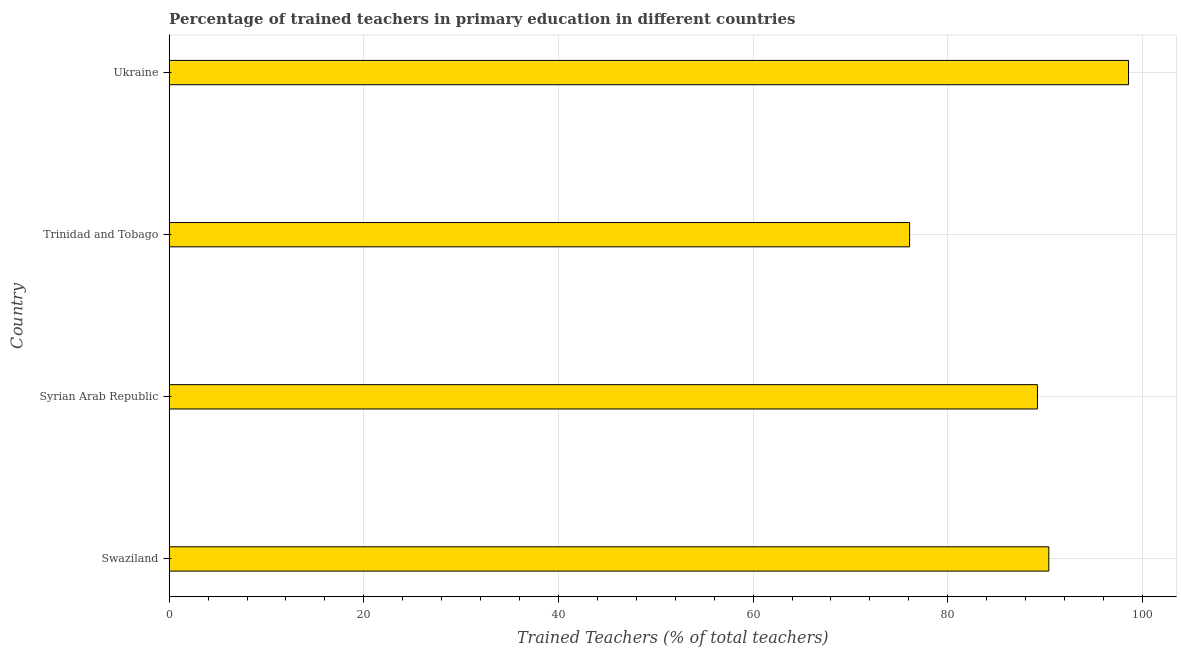Does the graph contain any zero values?
Offer a terse response. No. Does the graph contain grids?
Make the answer very short. Yes. What is the title of the graph?
Your response must be concise. Percentage of trained teachers in primary education in different countries. What is the label or title of the X-axis?
Give a very brief answer. Trained Teachers (% of total teachers). What is the label or title of the Y-axis?
Your answer should be compact. Country. What is the percentage of trained teachers in Syrian Arab Republic?
Provide a short and direct response. 89.21. Across all countries, what is the maximum percentage of trained teachers?
Offer a very short reply. 98.57. Across all countries, what is the minimum percentage of trained teachers?
Make the answer very short. 76.08. In which country was the percentage of trained teachers maximum?
Your response must be concise. Ukraine. In which country was the percentage of trained teachers minimum?
Ensure brevity in your answer.  Trinidad and Tobago. What is the sum of the percentage of trained teachers?
Give a very brief answer. 354.25. What is the difference between the percentage of trained teachers in Trinidad and Tobago and Ukraine?
Offer a very short reply. -22.5. What is the average percentage of trained teachers per country?
Offer a very short reply. 88.56. What is the median percentage of trained teachers?
Offer a terse response. 89.8. In how many countries, is the percentage of trained teachers greater than 80 %?
Your response must be concise. 3. What is the ratio of the percentage of trained teachers in Trinidad and Tobago to that in Ukraine?
Make the answer very short. 0.77. Is the difference between the percentage of trained teachers in Syrian Arab Republic and Trinidad and Tobago greater than the difference between any two countries?
Your answer should be very brief. No. What is the difference between the highest and the second highest percentage of trained teachers?
Provide a short and direct response. 8.19. In how many countries, is the percentage of trained teachers greater than the average percentage of trained teachers taken over all countries?
Your response must be concise. 3. How many countries are there in the graph?
Your response must be concise. 4. What is the difference between two consecutive major ticks on the X-axis?
Your answer should be very brief. 20. Are the values on the major ticks of X-axis written in scientific E-notation?
Give a very brief answer. No. What is the Trained Teachers (% of total teachers) in Swaziland?
Your answer should be very brief. 90.38. What is the Trained Teachers (% of total teachers) in Syrian Arab Republic?
Provide a succinct answer. 89.21. What is the Trained Teachers (% of total teachers) of Trinidad and Tobago?
Provide a short and direct response. 76.08. What is the Trained Teachers (% of total teachers) of Ukraine?
Your answer should be very brief. 98.57. What is the difference between the Trained Teachers (% of total teachers) in Swaziland and Syrian Arab Republic?
Make the answer very short. 1.17. What is the difference between the Trained Teachers (% of total teachers) in Swaziland and Trinidad and Tobago?
Your answer should be very brief. 14.31. What is the difference between the Trained Teachers (% of total teachers) in Swaziland and Ukraine?
Your response must be concise. -8.19. What is the difference between the Trained Teachers (% of total teachers) in Syrian Arab Republic and Trinidad and Tobago?
Ensure brevity in your answer.  13.14. What is the difference between the Trained Teachers (% of total teachers) in Syrian Arab Republic and Ukraine?
Provide a short and direct response. -9.36. What is the difference between the Trained Teachers (% of total teachers) in Trinidad and Tobago and Ukraine?
Ensure brevity in your answer.  -22.5. What is the ratio of the Trained Teachers (% of total teachers) in Swaziland to that in Syrian Arab Republic?
Your answer should be very brief. 1.01. What is the ratio of the Trained Teachers (% of total teachers) in Swaziland to that in Trinidad and Tobago?
Make the answer very short. 1.19. What is the ratio of the Trained Teachers (% of total teachers) in Swaziland to that in Ukraine?
Make the answer very short. 0.92. What is the ratio of the Trained Teachers (% of total teachers) in Syrian Arab Republic to that in Trinidad and Tobago?
Offer a very short reply. 1.17. What is the ratio of the Trained Teachers (% of total teachers) in Syrian Arab Republic to that in Ukraine?
Provide a succinct answer. 0.91. What is the ratio of the Trained Teachers (% of total teachers) in Trinidad and Tobago to that in Ukraine?
Your answer should be very brief. 0.77. 